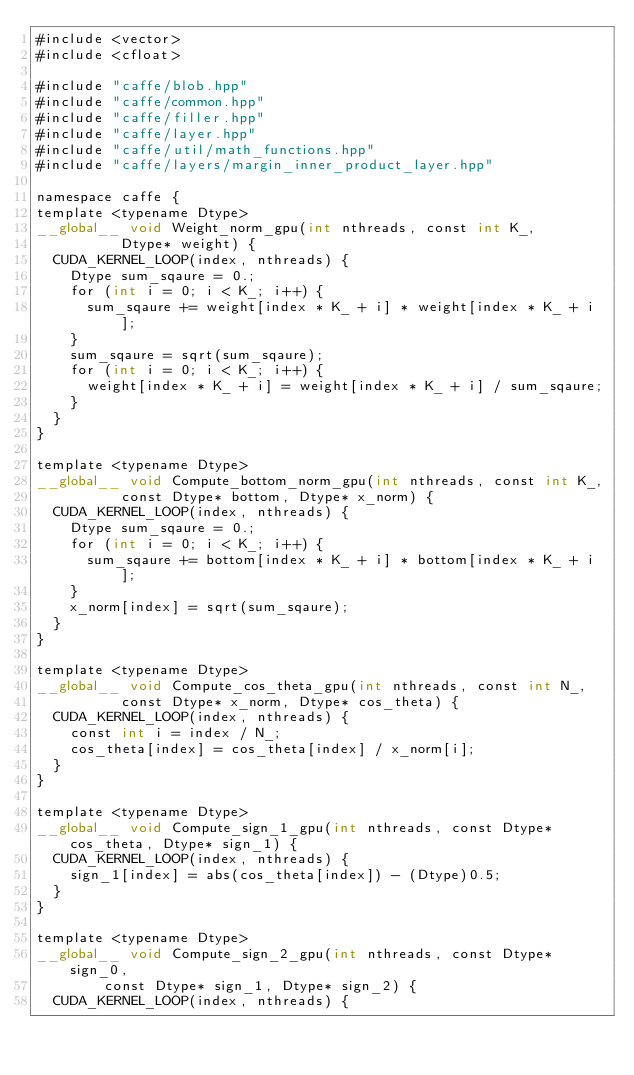<code> <loc_0><loc_0><loc_500><loc_500><_Cuda_>#include <vector>
#include <cfloat>

#include "caffe/blob.hpp"
#include "caffe/common.hpp"
#include "caffe/filler.hpp"
#include "caffe/layer.hpp"
#include "caffe/util/math_functions.hpp"
#include "caffe/layers/margin_inner_product_layer.hpp"

namespace caffe {
template <typename Dtype>
__global__ void Weight_norm_gpu(int nthreads, const int K_,
          Dtype* weight) {
  CUDA_KERNEL_LOOP(index, nthreads) {
  	Dtype sum_sqaure = 0.;
  	for (int i = 0; i < K_; i++) {
  	  sum_sqaure += weight[index * K_ + i] * weight[index * K_ + i];
  	}
  	sum_sqaure = sqrt(sum_sqaure);
    for (int i = 0; i < K_; i++) {
  	  weight[index * K_ + i] = weight[index * K_ + i] / sum_sqaure;
  	}
  }
}

template <typename Dtype>
__global__ void Compute_bottom_norm_gpu(int nthreads, const int K_,
          const Dtype* bottom, Dtype* x_norm) {
  CUDA_KERNEL_LOOP(index, nthreads) {
    Dtype sum_sqaure = 0.;
    for (int i = 0; i < K_; i++) {
      sum_sqaure += bottom[index * K_ + i] * bottom[index * K_ + i];
    }
    x_norm[index] = sqrt(sum_sqaure);
  }
}

template <typename Dtype>
__global__ void Compute_cos_theta_gpu(int nthreads, const int N_,
          const Dtype* x_norm, Dtype* cos_theta) {
  CUDA_KERNEL_LOOP(index, nthreads) {
    const int i = index / N_;
    cos_theta[index] = cos_theta[index] / x_norm[i];
  }
}

template <typename Dtype>
__global__ void Compute_sign_1_gpu(int nthreads, const Dtype* cos_theta, Dtype* sign_1) {
  CUDA_KERNEL_LOOP(index, nthreads) {
    sign_1[index] = abs(cos_theta[index]) - (Dtype)0.5;
  }
}

template <typename Dtype>
__global__ void Compute_sign_2_gpu(int nthreads, const Dtype* sign_0, 
	      const Dtype* sign_1, Dtype* sign_2) {
  CUDA_KERNEL_LOOP(index, nthreads) {</code> 